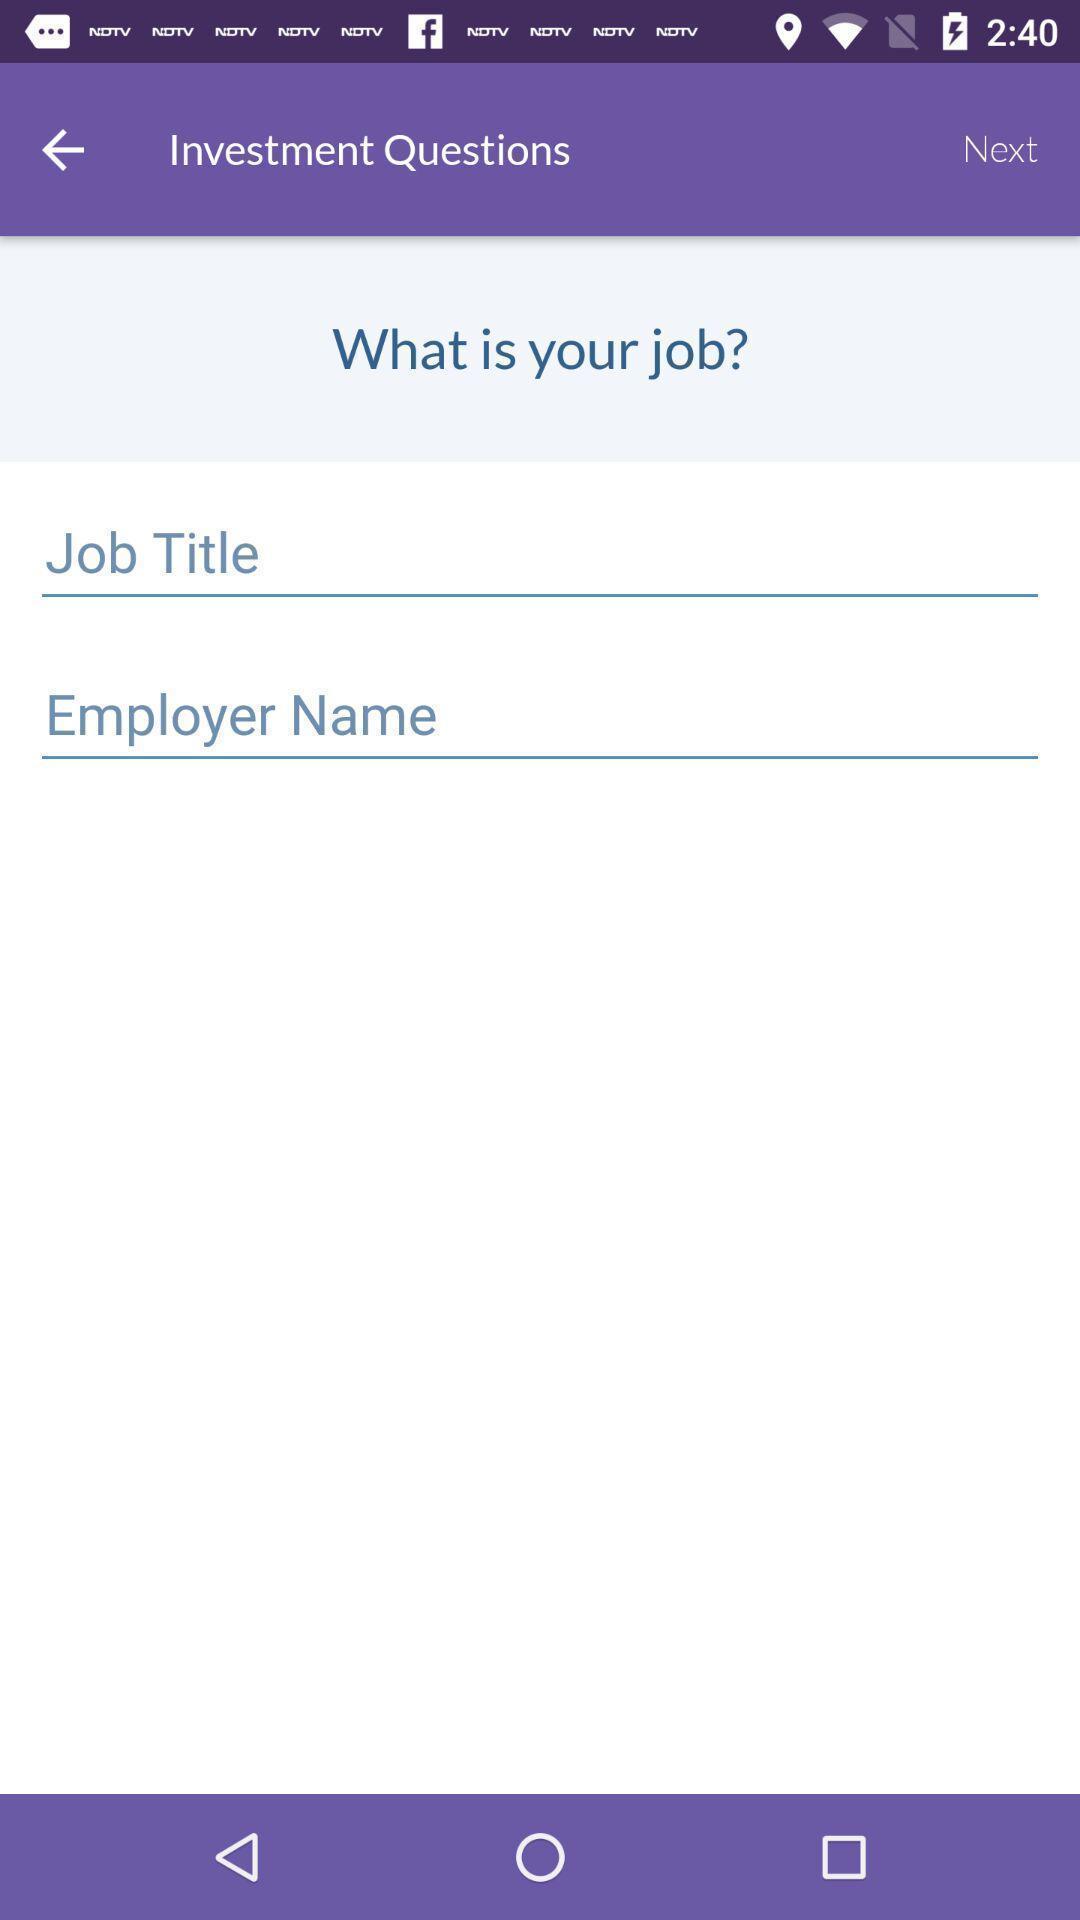Tell me what you see in this picture. Screen shows the employer details. 